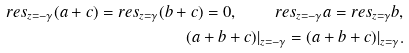<formula> <loc_0><loc_0><loc_500><loc_500>r e s _ { z = - \gamma } ( a + c ) = r e s _ { z = \gamma } ( b + c ) = 0 , \quad r e s _ { z = - \gamma } a = r e s _ { z = \gamma } b , \\ ( a + b + c ) | _ { z = - \gamma } = ( a + b + c ) | _ { z = \gamma } .</formula> 